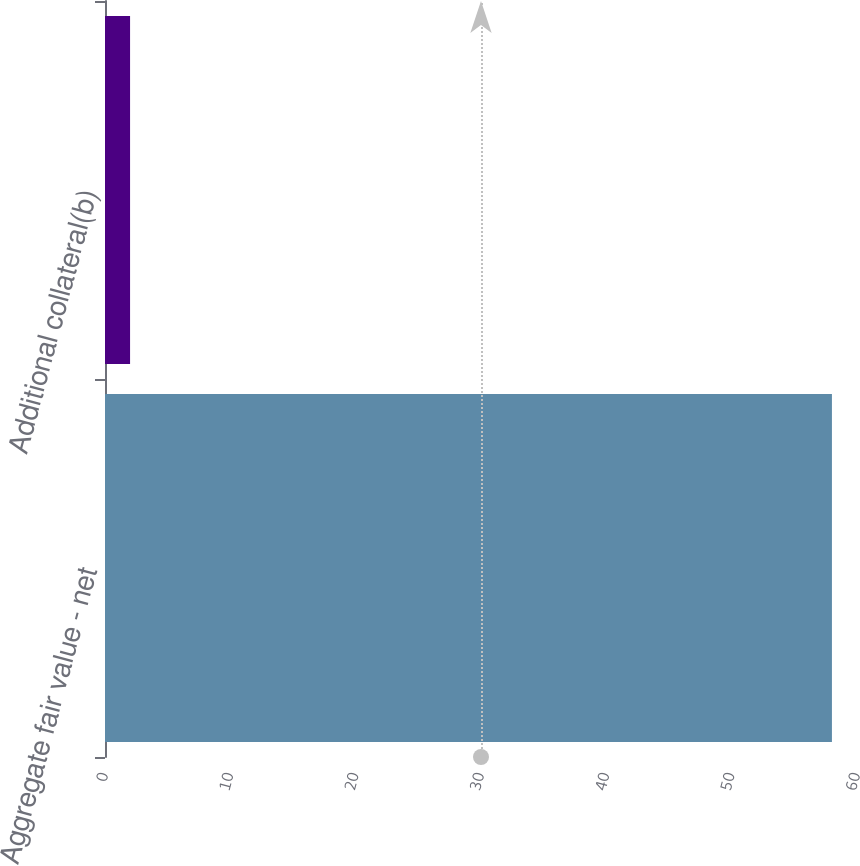Convert chart. <chart><loc_0><loc_0><loc_500><loc_500><bar_chart><fcel>Aggregate fair value - net<fcel>Additional collateral(b)<nl><fcel>58<fcel>2<nl></chart> 